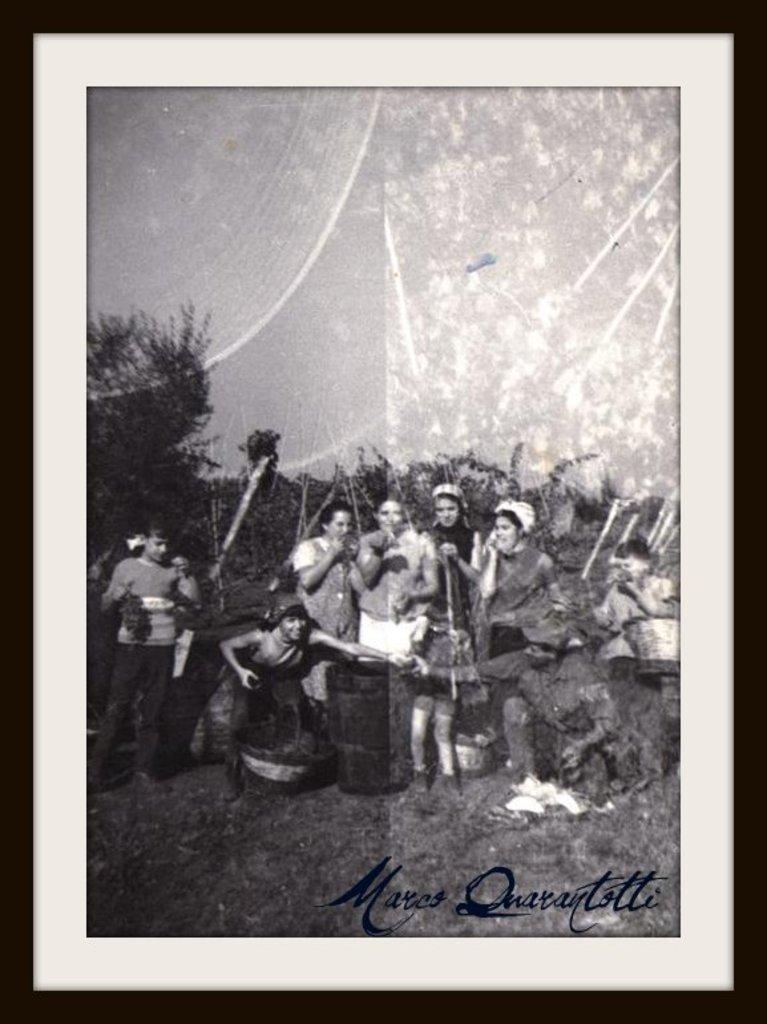What is the main object in the image? There is a photo frame in the image. What types of images are present in the photo frame? The photo frame contains images of people and trees. Are there any other objects present in the photo frame? Yes, there are other objects present in the photo frame. Can you describe the text in the right bottom corner of the image? There is text written in the right bottom corner of the image. What type of gold material is used to create the photo frame? There is no mention of gold or any specific material used to create the photo frame in the image. 